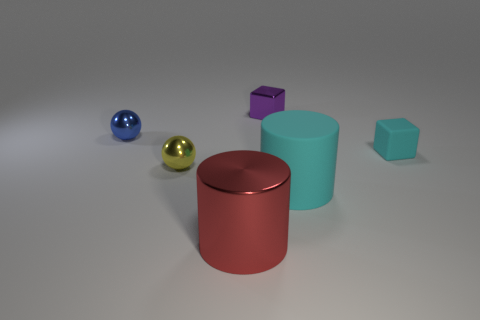Subtract all green spheres. How many cyan cylinders are left? 1 Subtract 1 cylinders. How many cylinders are left? 1 Subtract all yellow cubes. Subtract all gray spheres. How many cubes are left? 2 Subtract all big metal objects. Subtract all blue shiny spheres. How many objects are left? 4 Add 3 yellow balls. How many yellow balls are left? 4 Add 3 cyan rubber blocks. How many cyan rubber blocks exist? 4 Add 4 tiny things. How many objects exist? 10 Subtract 1 cyan blocks. How many objects are left? 5 Subtract all cylinders. How many objects are left? 4 